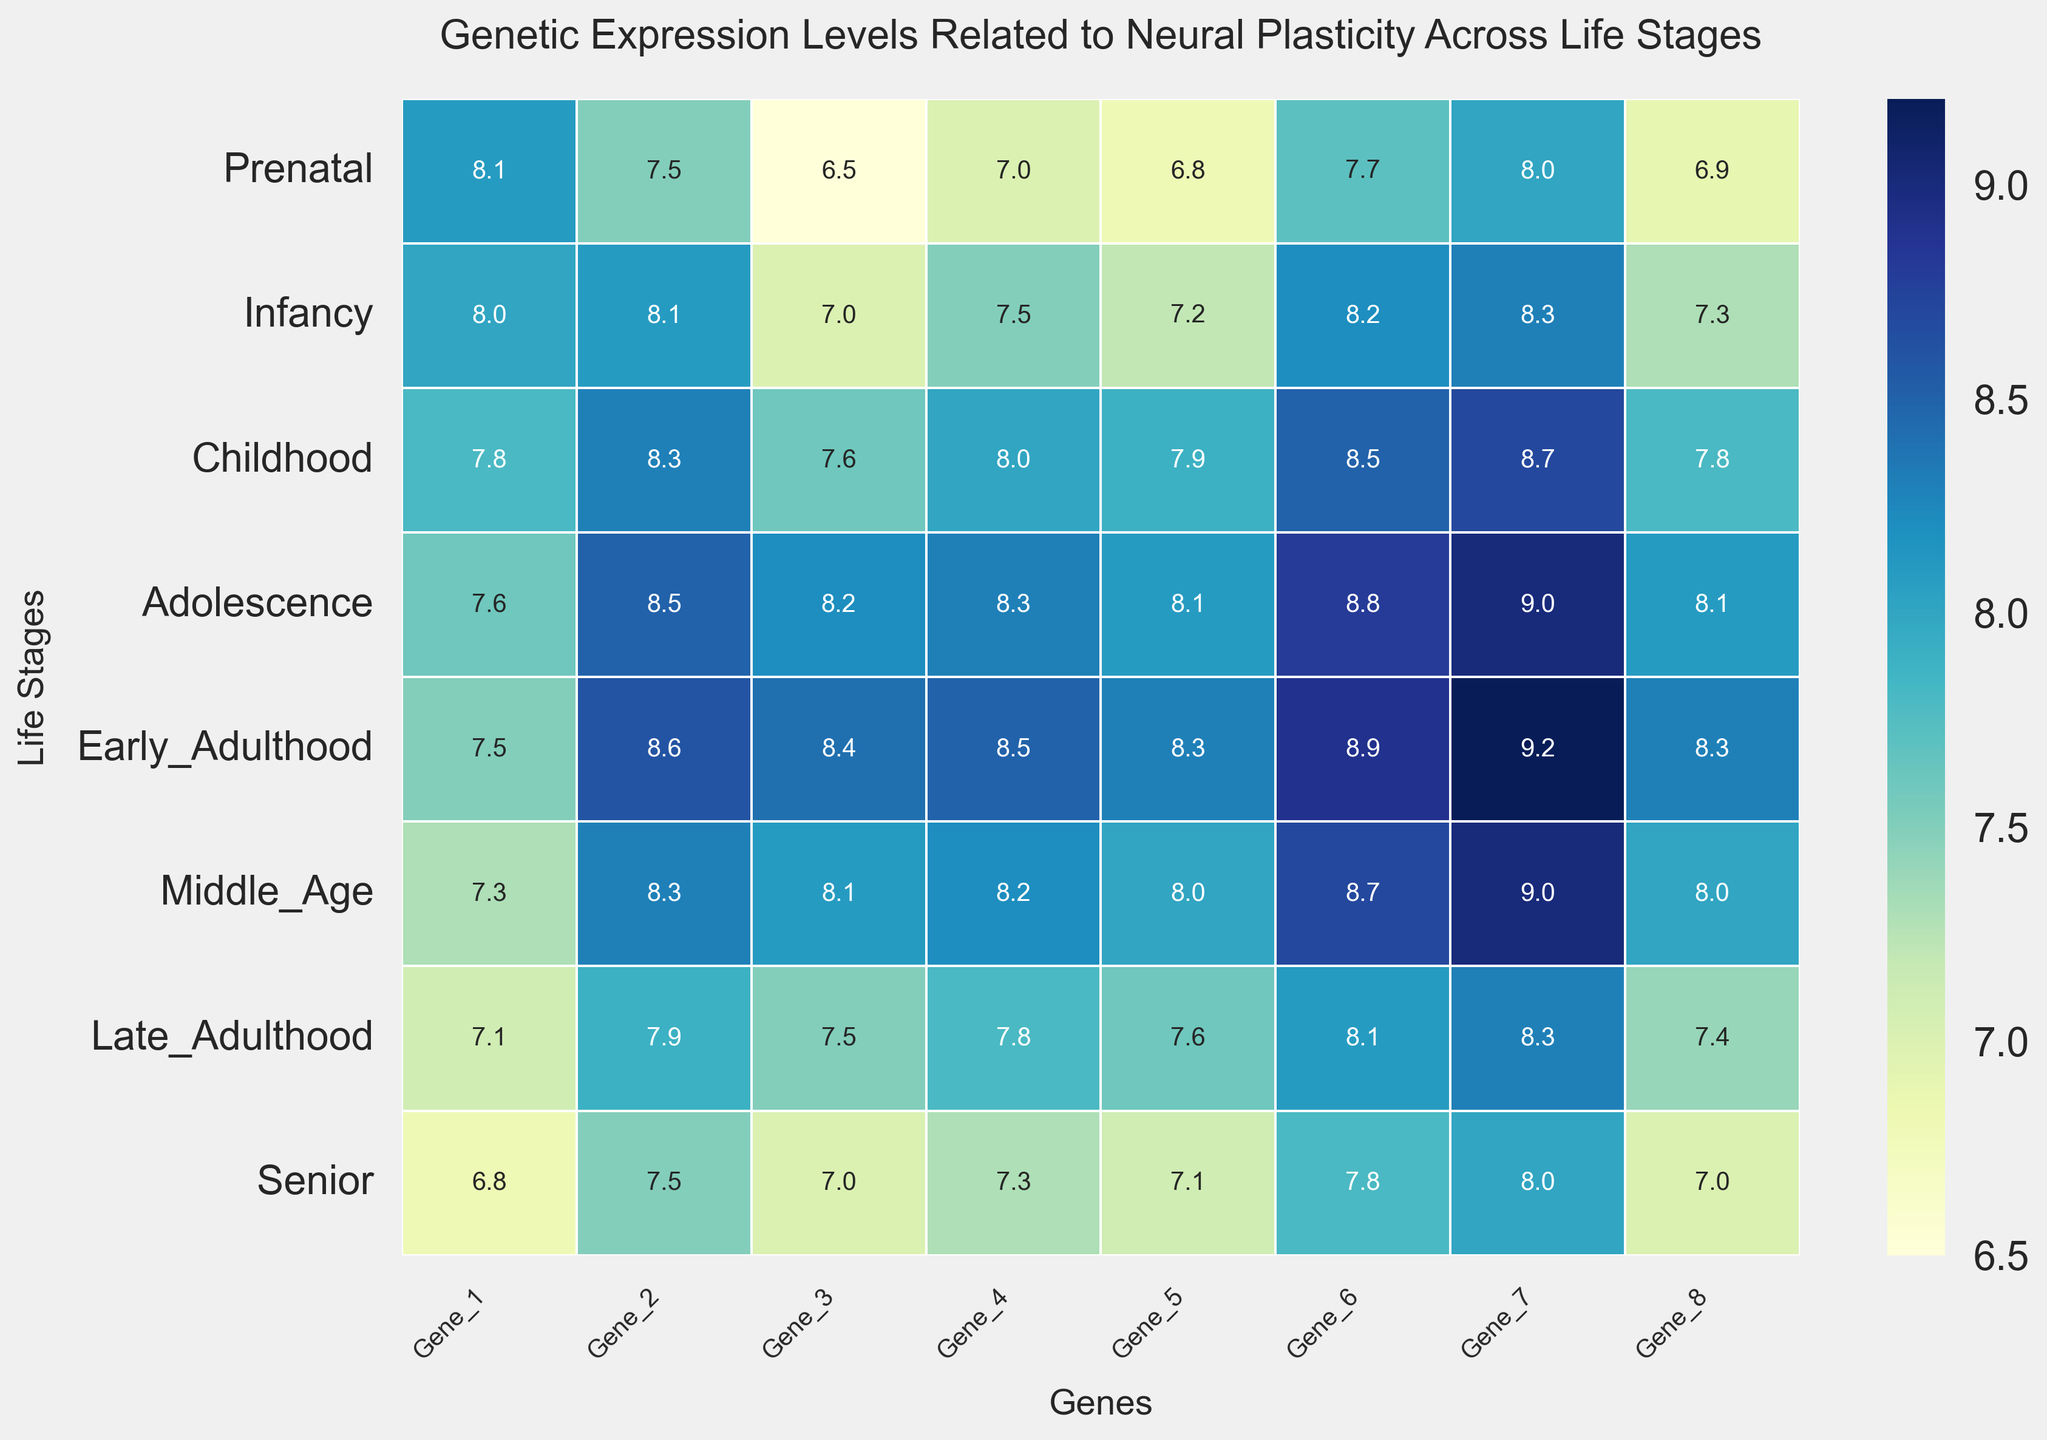Which life stage and gene combination has the highest expression level? Look at the heatmap and identify the cell with the darkest blue color. The highest expression level is indicated by the darkest color. This occurs in Early Adulthood for Gene 7.
Answer: Early Adulthood, Gene 7 What is the average expression level of Gene 3 across all life stages? Sum the expression levels of Gene 3 across all life stages (6.5 + 7.0 + 7.6 + 8.2 + 8.4 + 8.1 + 7.5 + 7.0) and divide by the number of stages (8). The calculation is (6.5 + 7.0 + 7.6 + 8.2 + 8.4 + 8.1 + 7.5 + 7.0) / 8 = 59.3 / 8.
Answer: 7.4 Which gene shows the largest increase in expression from Prenatal to Adolescence? Compare the increase in expression from Prenatal to Adolescence for each gene by subtracting Prenatal values from Adolescence values. The increases are: Gene 1: -0.5, Gene 2: 1.0, Gene 3: 1.7, Gene 4: 1.3, Gene 5: 1.3, Gene 6: 1.1, Gene 7: 1.0, Gene 8: 1.2. The largest increase is for Gene 3.
Answer: Gene 3 During which life stage does Gene 8 show a significant drop in expression compared to its previous stage? Observe the expression levels of Gene 8. Compare each stage with its previous one: from 6.9 (Prenatal) to 7.3 (Infancy), then to 7.8 (Childhood), then to 8.1 (Adolescence), etc. The significant drop is from Early Adulthood (8.3) to Late Adulthood (7.4).
Answer: Late Adulthood Is the expression level of Gene 5 higher or lower in Middle Age compared to Infancy? Compare the expression levels of Gene 5 in Middle Age (8.0) and Infancy (7.2). 8.0 is higher than 7.2.
Answer: Higher What's the total sum of the expression levels of Gene 2 across Childhood, Adolescence, and Early Adulthood? Add the values of Gene 2 in Childhood (8.3), Adolescence (8.5), and Early Adulthood (8.6). The calculation is 8.3 + 8.5 + 8.6 = 25.4.
Answer: 25.4 Which life stage shows the lowest expression level for Gene 6? Scan the heatmap for Gene 6 and find the lightest blue color, indicating the lowest value. The lowest expression level for Gene 6 is in Senior (7.8).
Answer: Senior Among the eight genes, which one has the highest expression level during Childhood? Identify the darkest blue cell among the values in the Childhood row. Gene 7 has the highest expression level at 8.7.
Answer: Gene 7 Which two life stages show the smallest difference in expression levels for Gene 4? Calculate the absolute differences in expression levels of Gene 4 between consecutive stages and identify the smallest difference. Smallest difference is between Prenatal (7.0) and Infancy (7.5), which is 0.5.
Answer: Prenatal and Infancy What is the overall trend of Gene 1 expression from Prenatal to Senior? Observe the changes in Gene 1 expression levels from Prenatal (8.1) to Senior (6.8). The overall trend is a gradual decrease.
Answer: Decreasing 